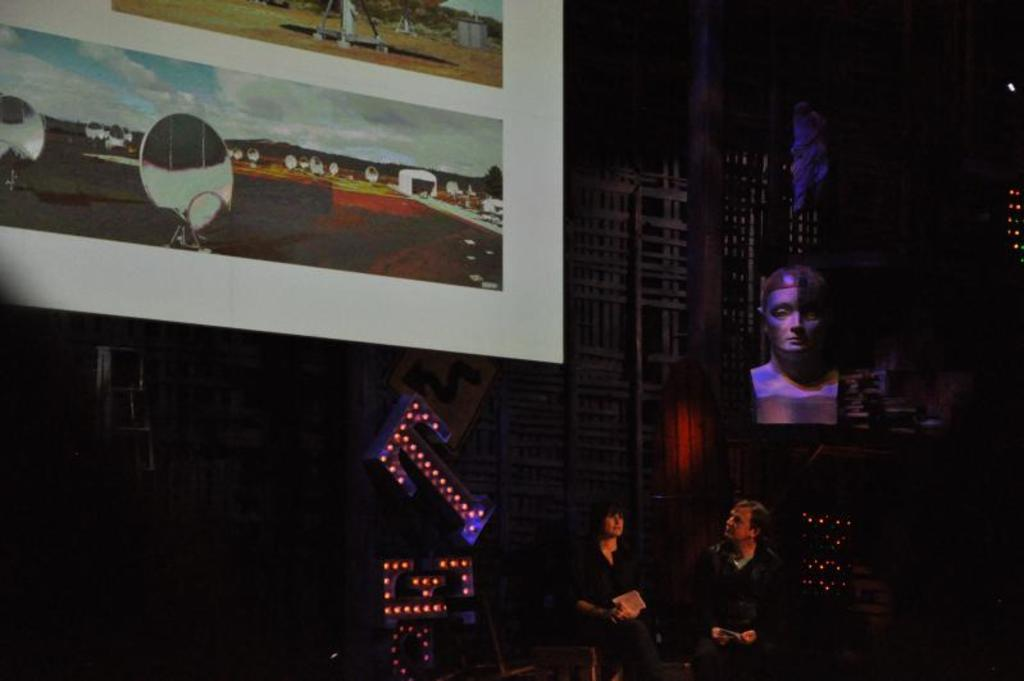What are the people in the image doing? There is a man and a woman sitting in the image. What is on the board that is visible in the image? There is a board with pictures in the image. What can be seen on the right side of the image? There is a statue and other objects on the right side of the image. How does the zephyr affect the ladybug in the image? There is no zephyr or ladybug present in the image. 